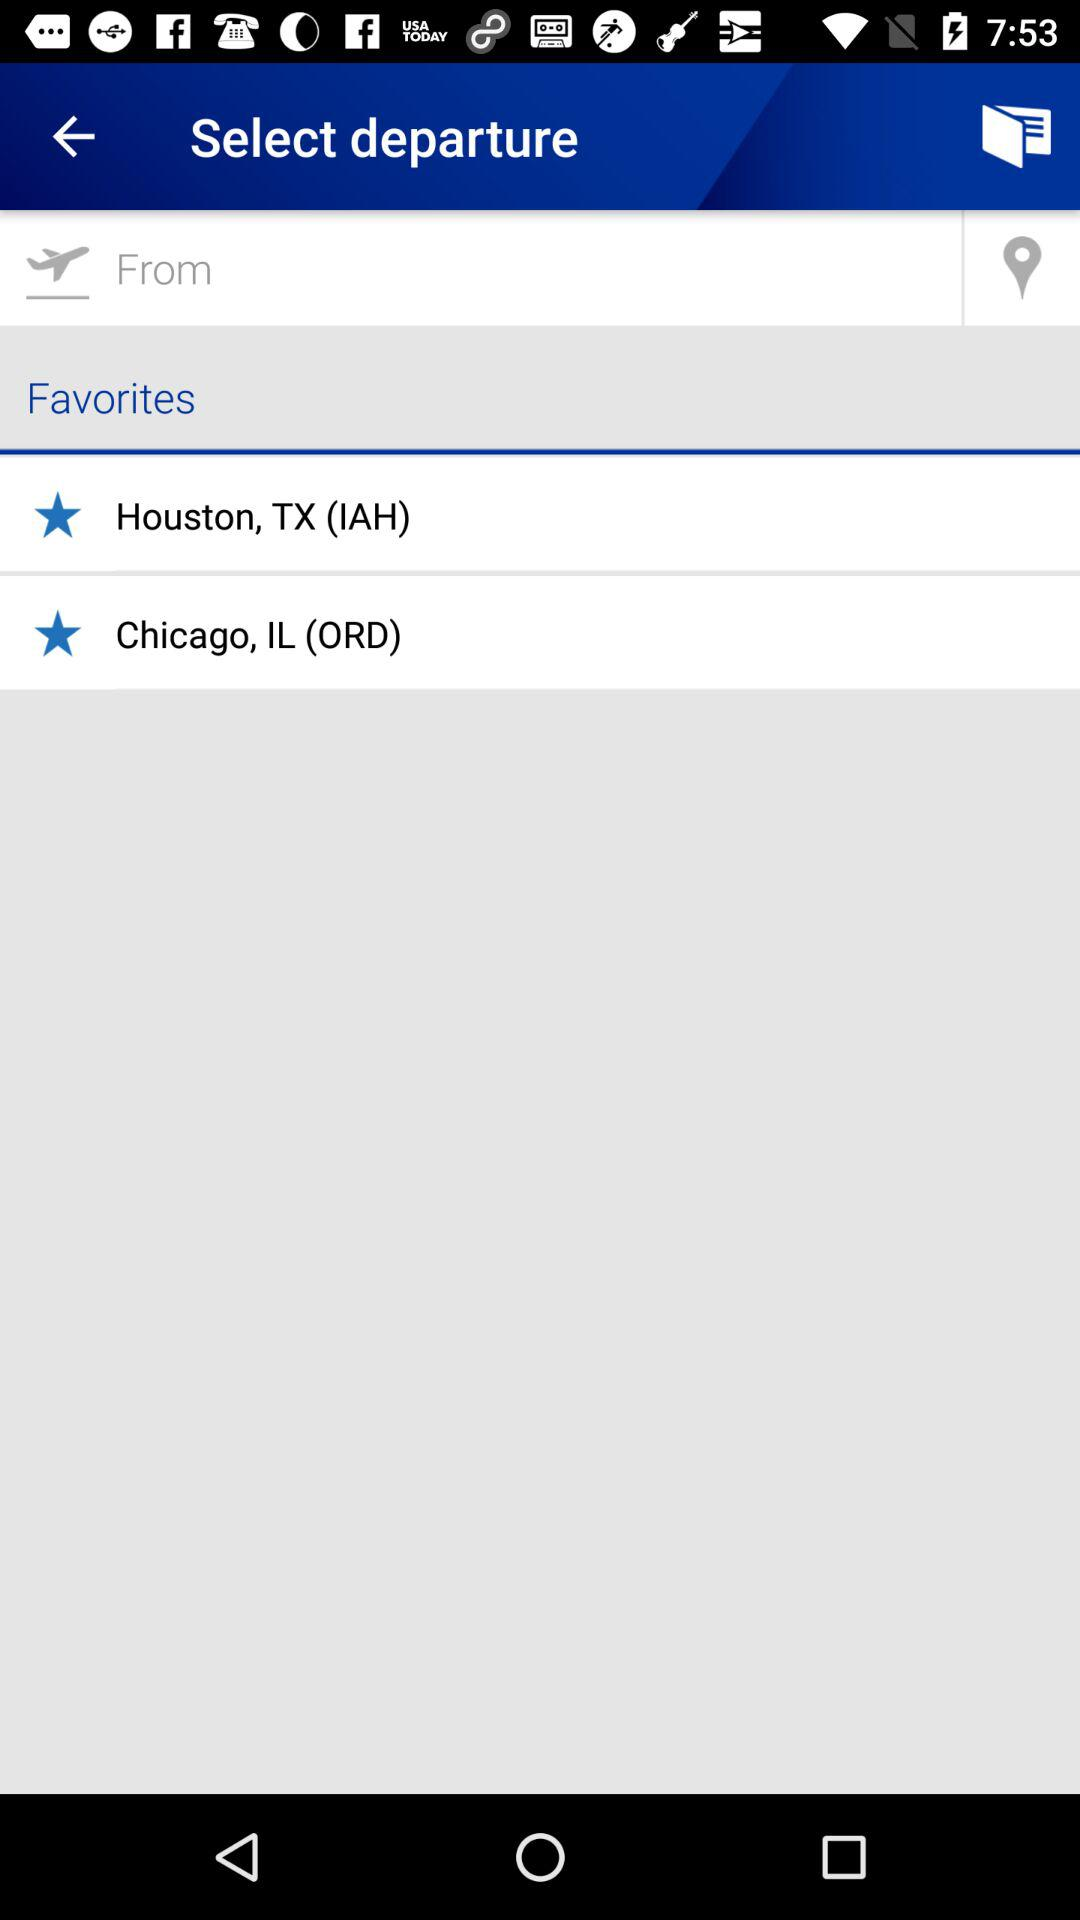What locations are added to the "Favorites" section? The locations added to the "Favorites" section are Houston, TX (IAH) and Chicago, IL (ORD). 